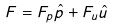<formula> <loc_0><loc_0><loc_500><loc_500>F = F _ { p } \hat { p } + F _ { u } \hat { u }</formula> 